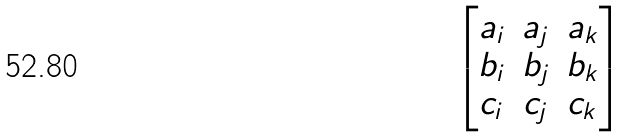<formula> <loc_0><loc_0><loc_500><loc_500>\begin{bmatrix} a _ { i } & a _ { j } & a _ { k } \\ b _ { i } & b _ { j } & b _ { k } \\ c _ { i } & c _ { j } & c _ { k } \end{bmatrix}</formula> 